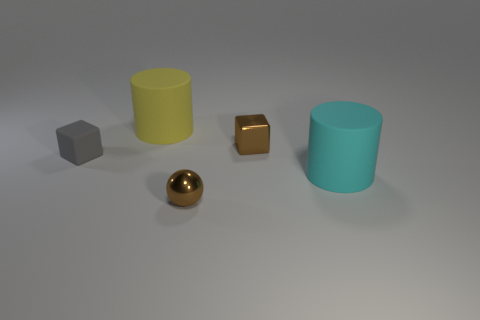Are there any large yellow shiny cylinders?
Your response must be concise. No. Is there a small block that has the same material as the small brown ball?
Provide a short and direct response. Yes. There is a gray cube that is the same size as the metallic ball; what is it made of?
Provide a succinct answer. Rubber. How many metallic things are the same shape as the gray rubber object?
Give a very brief answer. 1. The yellow cylinder that is the same material as the gray block is what size?
Offer a terse response. Large. What is the thing that is on the right side of the small sphere and in front of the brown block made of?
Provide a succinct answer. Rubber. What number of brown shiny objects are the same size as the brown shiny cube?
Your response must be concise. 1. What material is the other large thing that is the same shape as the big yellow rubber object?
Keep it short and to the point. Rubber. How many objects are either brown objects on the right side of the brown metal sphere or things that are in front of the brown cube?
Keep it short and to the point. 4. There is a yellow object; is it the same shape as the small brown metal object in front of the large cyan matte cylinder?
Your response must be concise. No. 